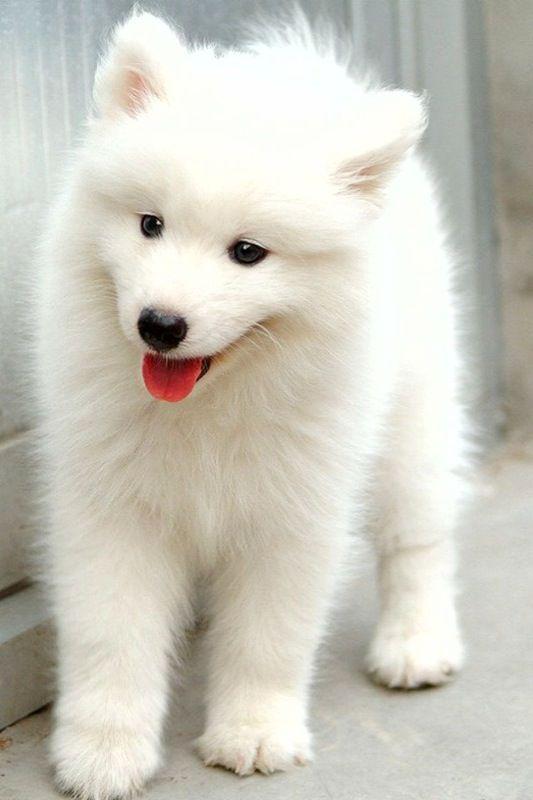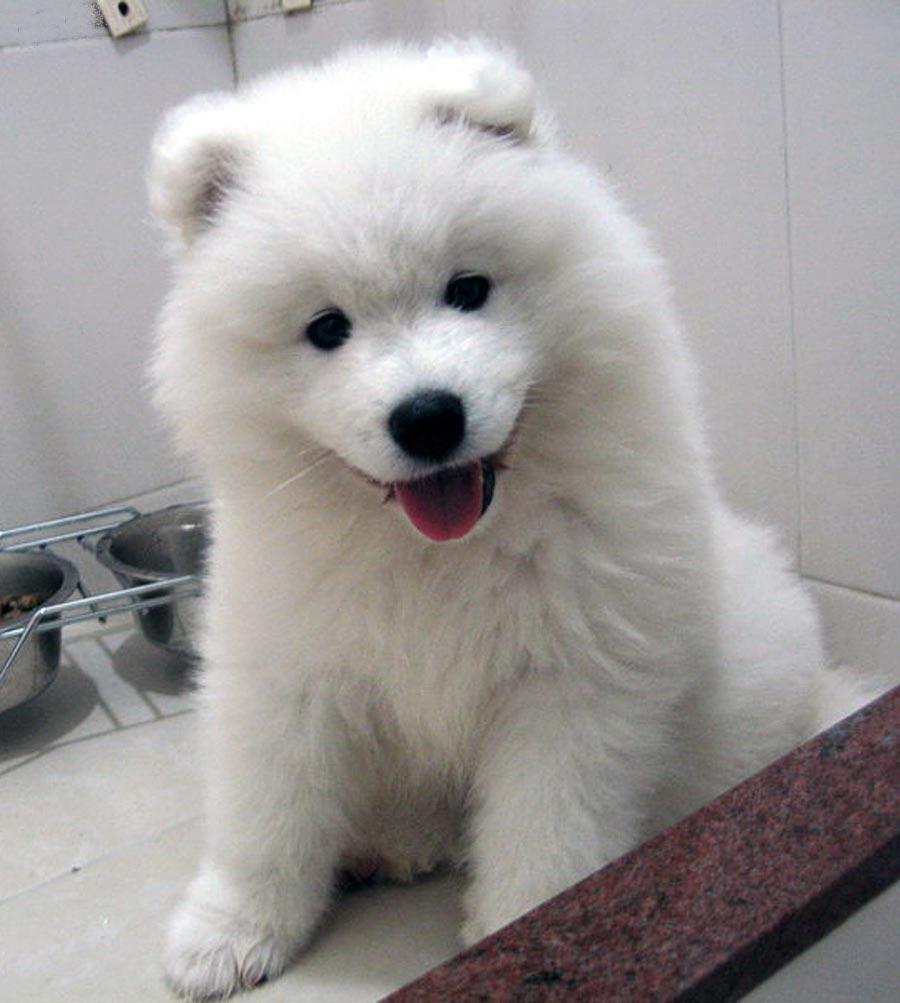The first image is the image on the left, the second image is the image on the right. For the images displayed, is the sentence "At least one image has an adult dog in it." factually correct? Answer yes or no. No. The first image is the image on the left, the second image is the image on the right. Considering the images on both sides, is "There is at least one white puppy sitting on the ground looking forward." valid? Answer yes or no. Yes. 